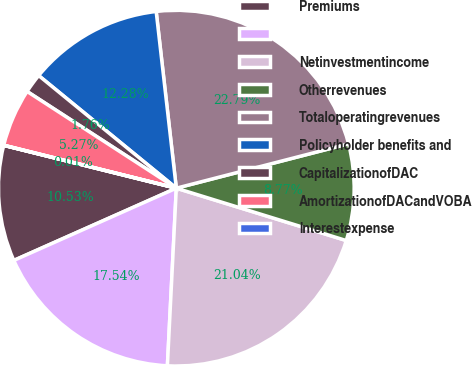<chart> <loc_0><loc_0><loc_500><loc_500><pie_chart><fcel>Premiums<fcel>Unnamed: 1<fcel>Netinvestmentincome<fcel>Otherrevenues<fcel>Totaloperatingrevenues<fcel>Policyholder benefits and<fcel>CapitalizationofDAC<fcel>AmortizationofDACandVOBA<fcel>Interestexpense<nl><fcel>10.53%<fcel>17.54%<fcel>21.04%<fcel>8.77%<fcel>22.79%<fcel>12.28%<fcel>1.76%<fcel>5.27%<fcel>0.01%<nl></chart> 